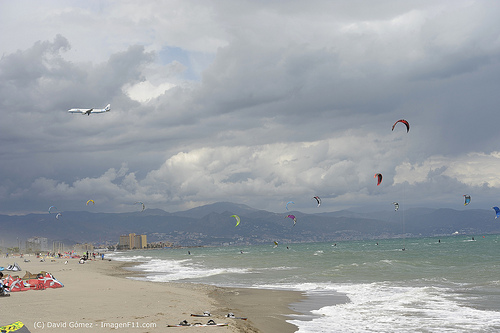Please provide the bounding box coordinate of the region this sentence describes: this is a building. The bounding box coordinates for the region described as 'this is a building' are [0.24, 0.63, 0.31, 0.67]. 